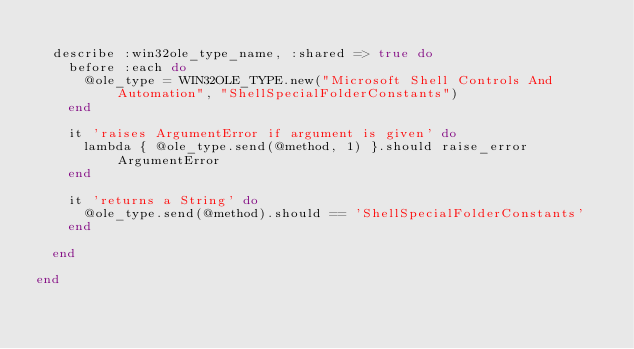<code> <loc_0><loc_0><loc_500><loc_500><_Ruby_>  
  describe :win32ole_type_name, :shared => true do
    before :each do
      @ole_type = WIN32OLE_TYPE.new("Microsoft Shell Controls And Automation", "ShellSpecialFolderConstants")
    end
    
    it 'raises ArgumentError if argument is given' do
      lambda { @ole_type.send(@method, 1) }.should raise_error ArgumentError
    end
    
    it 'returns a String' do
      @ole_type.send(@method).should == 'ShellSpecialFolderConstants'
    end
    
  end
  
end</code> 